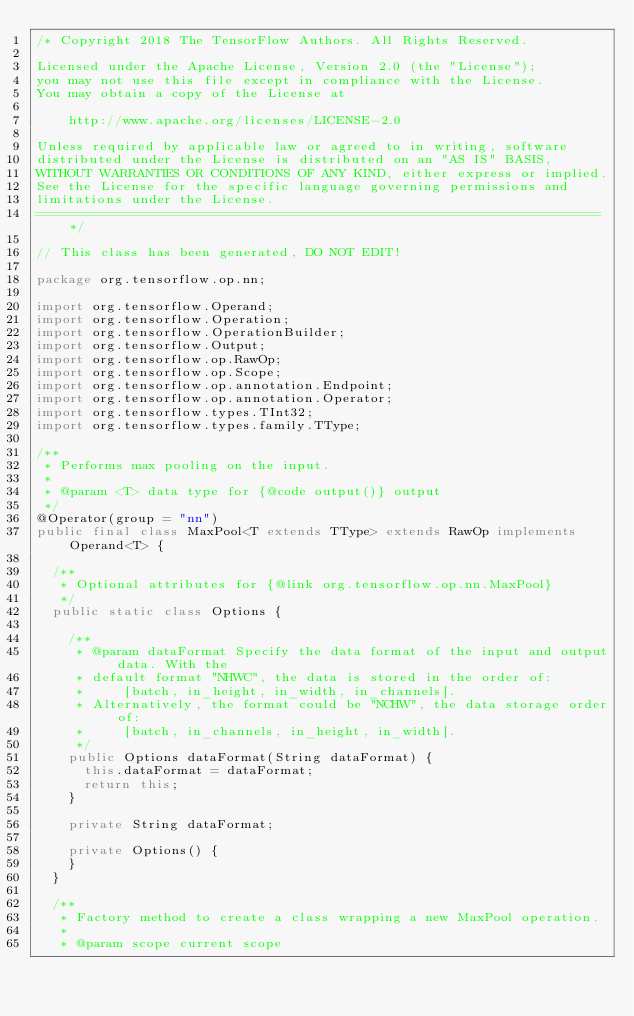<code> <loc_0><loc_0><loc_500><loc_500><_Java_>/* Copyright 2018 The TensorFlow Authors. All Rights Reserved.

Licensed under the Apache License, Version 2.0 (the "License");
you may not use this file except in compliance with the License.
You may obtain a copy of the License at

    http://www.apache.org/licenses/LICENSE-2.0

Unless required by applicable law or agreed to in writing, software
distributed under the License is distributed on an "AS IS" BASIS,
WITHOUT WARRANTIES OR CONDITIONS OF ANY KIND, either express or implied.
See the License for the specific language governing permissions and
limitations under the License.
=======================================================================*/

// This class has been generated, DO NOT EDIT!

package org.tensorflow.op.nn;

import org.tensorflow.Operand;
import org.tensorflow.Operation;
import org.tensorflow.OperationBuilder;
import org.tensorflow.Output;
import org.tensorflow.op.RawOp;
import org.tensorflow.op.Scope;
import org.tensorflow.op.annotation.Endpoint;
import org.tensorflow.op.annotation.Operator;
import org.tensorflow.types.TInt32;
import org.tensorflow.types.family.TType;

/**
 * Performs max pooling on the input.
 * 
 * @param <T> data type for {@code output()} output
 */
@Operator(group = "nn")
public final class MaxPool<T extends TType> extends RawOp implements Operand<T> {
  
  /**
   * Optional attributes for {@link org.tensorflow.op.nn.MaxPool}
   */
  public static class Options {
    
    /**
     * @param dataFormat Specify the data format of the input and output data. With the
     * default format "NHWC", the data is stored in the order of:
     *     [batch, in_height, in_width, in_channels].
     * Alternatively, the format could be "NCHW", the data storage order of:
     *     [batch, in_channels, in_height, in_width].
     */
    public Options dataFormat(String dataFormat) {
      this.dataFormat = dataFormat;
      return this;
    }
    
    private String dataFormat;
    
    private Options() {
    }
  }
  
  /**
   * Factory method to create a class wrapping a new MaxPool operation.
   * 
   * @param scope current scope</code> 